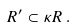<formula> <loc_0><loc_0><loc_500><loc_500>R ^ { \prime } \subset \kappa R \, .</formula> 